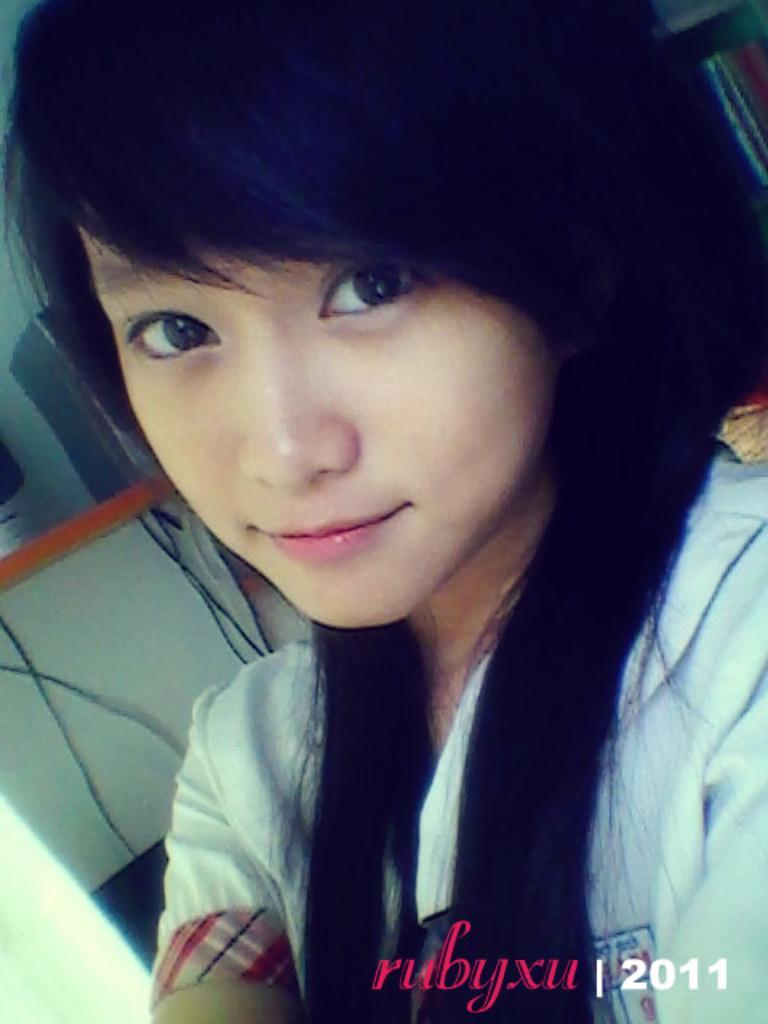Describe this image in one or two sentences. In this image in the foreground there is one woman, and in the background there is a table, wires and some objects. At the bottom of the image there is text. 